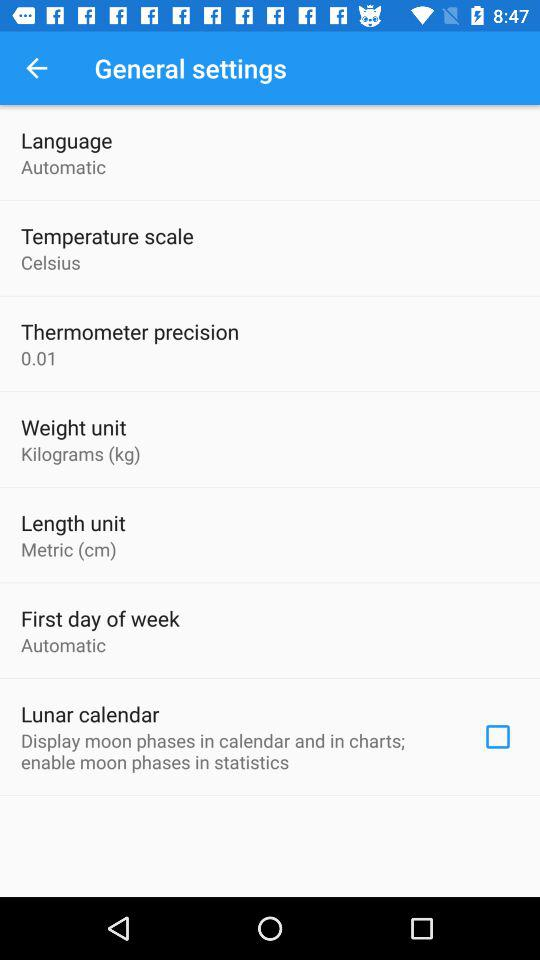Which type of language is selected? The selected language is "Automatic". 